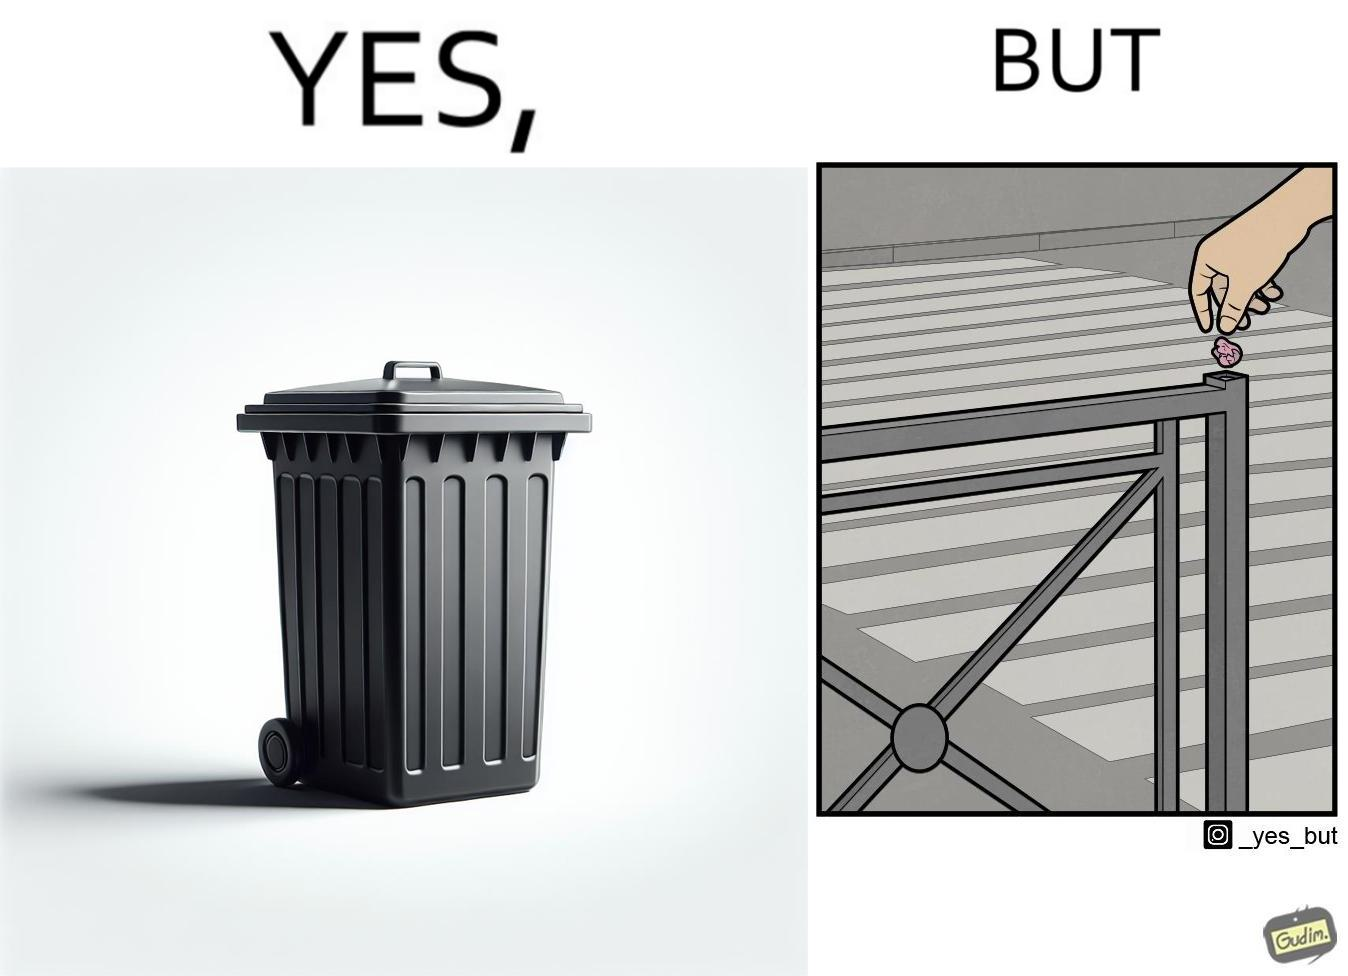Describe the contrast between the left and right parts of this image. In the left part of the image: It is a garbage bin In the right part of the image: It is a human hand sticking chewing gum on public property 